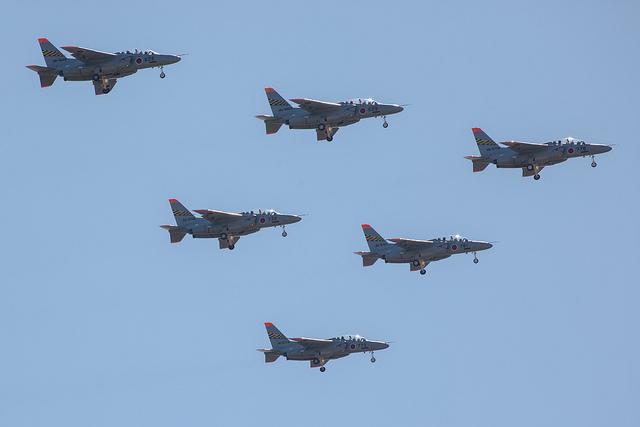Is that a flock of fancy birds?
Keep it brief. No. Does this formation take a lot of practice to achieve?
Concise answer only. Yes. What type of planes are these?
Keep it brief. Jets. 